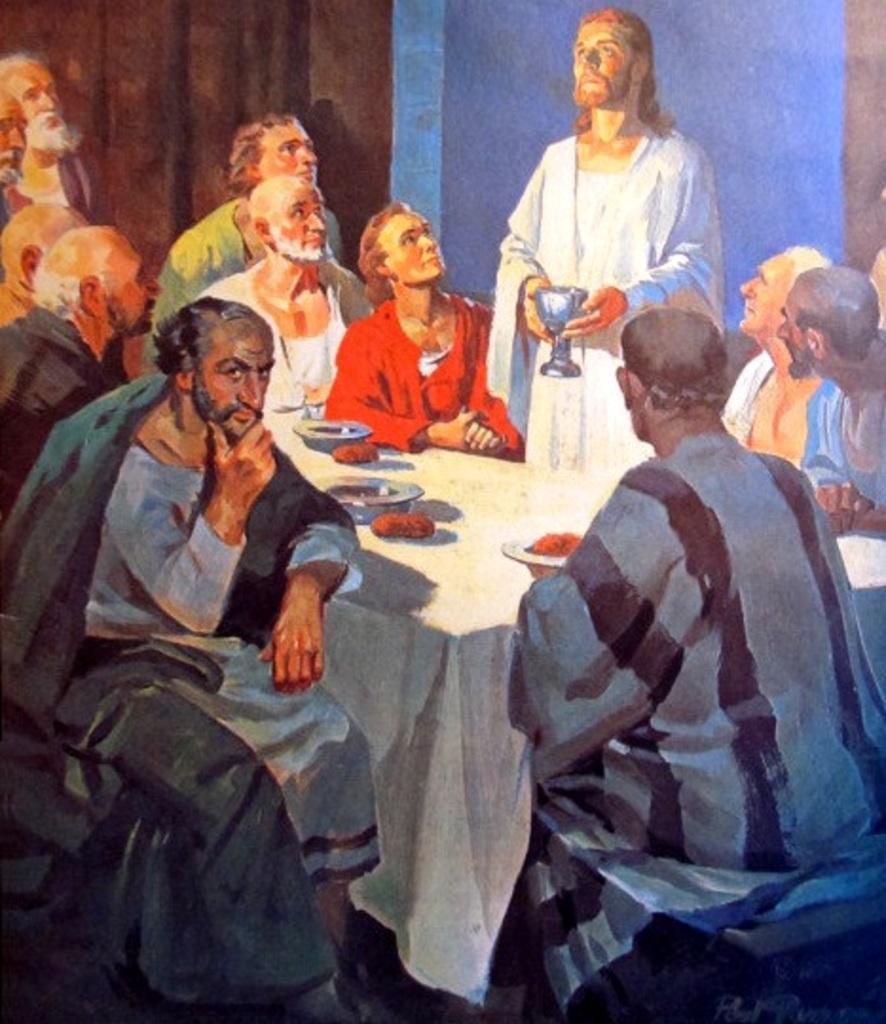Could you give a brief overview of what you see in this image? In this image there is a painting, there are a group of men sitting, there is a man standing, he is holding an object, there is a table, there is a cloth on the table, there are objects on the cloth, there is a wall behind the men. 